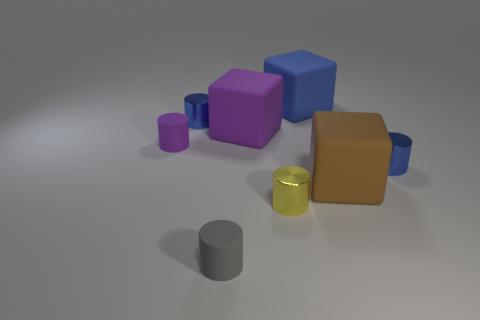Subtract all tiny yellow shiny cylinders. How many cylinders are left? 4 Subtract 4 cylinders. How many cylinders are left? 1 Add 1 big purple blocks. How many objects exist? 9 Subtract all purple cylinders. How many cylinders are left? 4 Subtract 0 purple spheres. How many objects are left? 8 Subtract all cubes. How many objects are left? 5 Subtract all cyan cylinders. Subtract all gray spheres. How many cylinders are left? 5 Subtract all cyan cylinders. How many brown cubes are left? 1 Subtract all tiny yellow metal objects. Subtract all gray things. How many objects are left? 6 Add 8 brown cubes. How many brown cubes are left? 9 